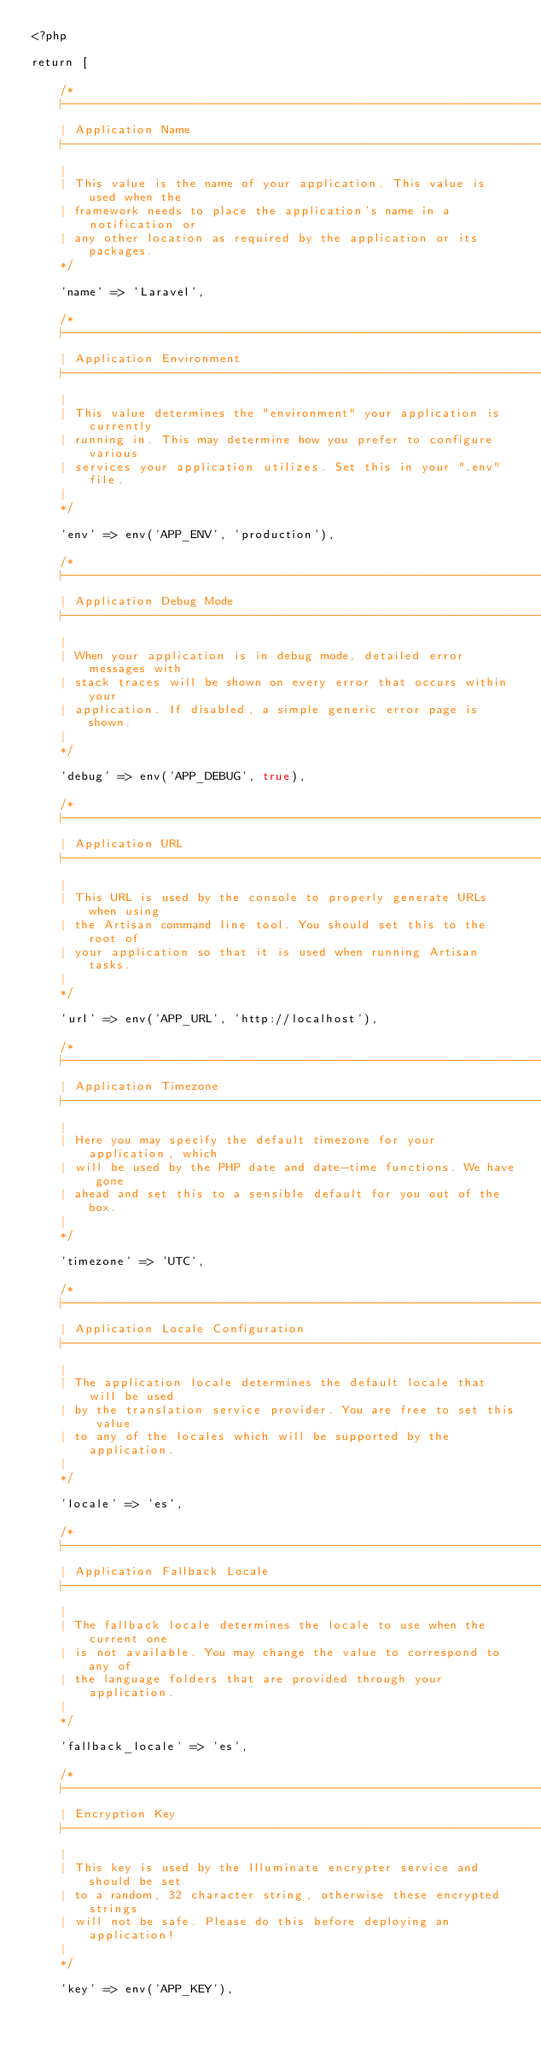<code> <loc_0><loc_0><loc_500><loc_500><_PHP_><?php

return [

    /*
    |--------------------------------------------------------------------------
    | Application Name
    |--------------------------------------------------------------------------
    |
    | This value is the name of your application. This value is used when the
    | framework needs to place the application's name in a notification or
    | any other location as required by the application or its packages.
    */

    'name' => 'Laravel',

    /*
    |--------------------------------------------------------------------------
    | Application Environment
    |--------------------------------------------------------------------------
    |
    | This value determines the "environment" your application is currently
    | running in. This may determine how you prefer to configure various
    | services your application utilizes. Set this in your ".env" file.
    |
    */

    'env' => env('APP_ENV', 'production'),

    /*
    |--------------------------------------------------------------------------
    | Application Debug Mode
    |--------------------------------------------------------------------------
    |
    | When your application is in debug mode, detailed error messages with
    | stack traces will be shown on every error that occurs within your
    | application. If disabled, a simple generic error page is shown.
    |
    */

    'debug' => env('APP_DEBUG', true),

    /*
    |--------------------------------------------------------------------------
    | Application URL
    |--------------------------------------------------------------------------
    |
    | This URL is used by the console to properly generate URLs when using
    | the Artisan command line tool. You should set this to the root of
    | your application so that it is used when running Artisan tasks.
    |
    */

    'url' => env('APP_URL', 'http://localhost'),

    /*
    |--------------------------------------------------------------------------
    | Application Timezone
    |--------------------------------------------------------------------------
    |
    | Here you may specify the default timezone for your application, which
    | will be used by the PHP date and date-time functions. We have gone
    | ahead and set this to a sensible default for you out of the box.
    |
    */

    'timezone' => 'UTC',

    /*
    |--------------------------------------------------------------------------
    | Application Locale Configuration
    |--------------------------------------------------------------------------
    |
    | The application locale determines the default locale that will be used
    | by the translation service provider. You are free to set this value
    | to any of the locales which will be supported by the application.
    |
    */

    'locale' => 'es',

    /*
    |--------------------------------------------------------------------------
    | Application Fallback Locale
    |--------------------------------------------------------------------------
    |
    | The fallback locale determines the locale to use when the current one
    | is not available. You may change the value to correspond to any of
    | the language folders that are provided through your application.
    |
    */

    'fallback_locale' => 'es',

    /*
    |--------------------------------------------------------------------------
    | Encryption Key
    |--------------------------------------------------------------------------
    |
    | This key is used by the Illuminate encrypter service and should be set
    | to a random, 32 character string, otherwise these encrypted strings
    | will not be safe. Please do this before deploying an application!
    |
    */

    'key' => env('APP_KEY'),
</code> 